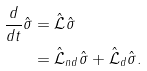Convert formula to latex. <formula><loc_0><loc_0><loc_500><loc_500>\frac { d } { d t } \hat { \sigma } & = \hat { \mathcal { L } } \hat { \sigma } \\ & = \hat { \mathcal { L } } _ { n d } \hat { \sigma } + \hat { \mathcal { L } } _ { d } \hat { \sigma } .</formula> 